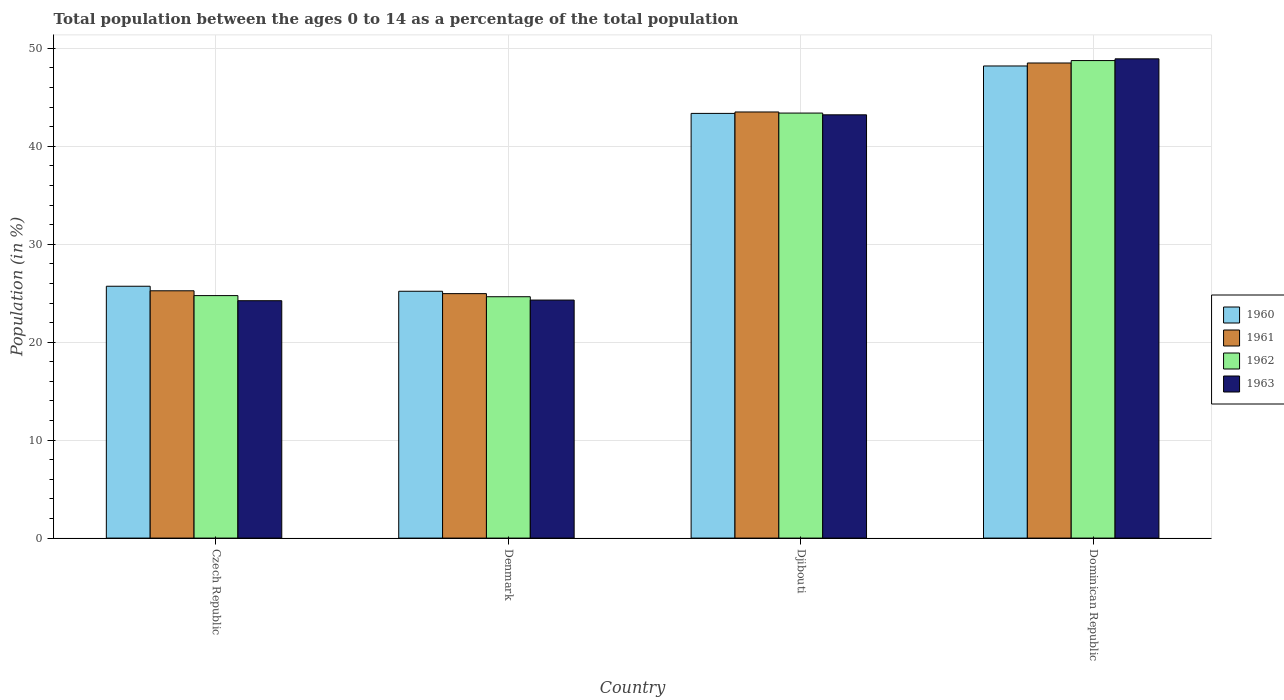How many different coloured bars are there?
Provide a short and direct response. 4. How many groups of bars are there?
Your answer should be very brief. 4. Are the number of bars per tick equal to the number of legend labels?
Your response must be concise. Yes. What is the label of the 3rd group of bars from the left?
Provide a succinct answer. Djibouti. In how many cases, is the number of bars for a given country not equal to the number of legend labels?
Provide a succinct answer. 0. What is the percentage of the population ages 0 to 14 in 1962 in Dominican Republic?
Your answer should be very brief. 48.75. Across all countries, what is the maximum percentage of the population ages 0 to 14 in 1963?
Ensure brevity in your answer.  48.93. Across all countries, what is the minimum percentage of the population ages 0 to 14 in 1962?
Offer a very short reply. 24.64. In which country was the percentage of the population ages 0 to 14 in 1962 maximum?
Ensure brevity in your answer.  Dominican Republic. What is the total percentage of the population ages 0 to 14 in 1962 in the graph?
Provide a short and direct response. 141.54. What is the difference between the percentage of the population ages 0 to 14 in 1961 in Czech Republic and that in Djibouti?
Make the answer very short. -18.26. What is the difference between the percentage of the population ages 0 to 14 in 1963 in Dominican Republic and the percentage of the population ages 0 to 14 in 1962 in Denmark?
Your answer should be compact. 24.29. What is the average percentage of the population ages 0 to 14 in 1960 per country?
Provide a succinct answer. 35.62. What is the difference between the percentage of the population ages 0 to 14 of/in 1960 and percentage of the population ages 0 to 14 of/in 1963 in Denmark?
Provide a short and direct response. 0.9. What is the ratio of the percentage of the population ages 0 to 14 in 1962 in Denmark to that in Djibouti?
Offer a very short reply. 0.57. Is the percentage of the population ages 0 to 14 in 1962 in Djibouti less than that in Dominican Republic?
Your answer should be compact. Yes. What is the difference between the highest and the second highest percentage of the population ages 0 to 14 in 1961?
Offer a terse response. 23.26. What is the difference between the highest and the lowest percentage of the population ages 0 to 14 in 1962?
Your answer should be very brief. 24.11. Is it the case that in every country, the sum of the percentage of the population ages 0 to 14 in 1961 and percentage of the population ages 0 to 14 in 1960 is greater than the sum of percentage of the population ages 0 to 14 in 1962 and percentage of the population ages 0 to 14 in 1963?
Your answer should be compact. No. How many bars are there?
Give a very brief answer. 16. What is the difference between two consecutive major ticks on the Y-axis?
Make the answer very short. 10. Are the values on the major ticks of Y-axis written in scientific E-notation?
Keep it short and to the point. No. Does the graph contain any zero values?
Provide a short and direct response. No. How are the legend labels stacked?
Provide a succinct answer. Vertical. What is the title of the graph?
Give a very brief answer. Total population between the ages 0 to 14 as a percentage of the total population. Does "1993" appear as one of the legend labels in the graph?
Offer a terse response. No. What is the label or title of the Y-axis?
Your answer should be compact. Population (in %). What is the Population (in %) of 1960 in Czech Republic?
Offer a very short reply. 25.71. What is the Population (in %) in 1961 in Czech Republic?
Ensure brevity in your answer.  25.25. What is the Population (in %) of 1962 in Czech Republic?
Make the answer very short. 24.76. What is the Population (in %) of 1963 in Czech Republic?
Offer a very short reply. 24.23. What is the Population (in %) of 1960 in Denmark?
Keep it short and to the point. 25.2. What is the Population (in %) of 1961 in Denmark?
Offer a terse response. 24.96. What is the Population (in %) of 1962 in Denmark?
Provide a succinct answer. 24.64. What is the Population (in %) in 1963 in Denmark?
Give a very brief answer. 24.3. What is the Population (in %) in 1960 in Djibouti?
Ensure brevity in your answer.  43.36. What is the Population (in %) of 1961 in Djibouti?
Offer a very short reply. 43.5. What is the Population (in %) in 1962 in Djibouti?
Keep it short and to the point. 43.39. What is the Population (in %) of 1963 in Djibouti?
Keep it short and to the point. 43.21. What is the Population (in %) of 1960 in Dominican Republic?
Make the answer very short. 48.2. What is the Population (in %) in 1961 in Dominican Republic?
Your answer should be very brief. 48.5. What is the Population (in %) in 1962 in Dominican Republic?
Give a very brief answer. 48.75. What is the Population (in %) of 1963 in Dominican Republic?
Ensure brevity in your answer.  48.93. Across all countries, what is the maximum Population (in %) in 1960?
Make the answer very short. 48.2. Across all countries, what is the maximum Population (in %) in 1961?
Your answer should be very brief. 48.5. Across all countries, what is the maximum Population (in %) in 1962?
Keep it short and to the point. 48.75. Across all countries, what is the maximum Population (in %) in 1963?
Offer a terse response. 48.93. Across all countries, what is the minimum Population (in %) in 1960?
Your response must be concise. 25.2. Across all countries, what is the minimum Population (in %) of 1961?
Make the answer very short. 24.96. Across all countries, what is the minimum Population (in %) of 1962?
Keep it short and to the point. 24.64. Across all countries, what is the minimum Population (in %) of 1963?
Make the answer very short. 24.23. What is the total Population (in %) of 1960 in the graph?
Provide a succinct answer. 142.47. What is the total Population (in %) of 1961 in the graph?
Your answer should be very brief. 142.22. What is the total Population (in %) in 1962 in the graph?
Keep it short and to the point. 141.54. What is the total Population (in %) of 1963 in the graph?
Your response must be concise. 140.68. What is the difference between the Population (in %) in 1960 in Czech Republic and that in Denmark?
Provide a succinct answer. 0.51. What is the difference between the Population (in %) of 1961 in Czech Republic and that in Denmark?
Provide a short and direct response. 0.29. What is the difference between the Population (in %) in 1962 in Czech Republic and that in Denmark?
Provide a succinct answer. 0.12. What is the difference between the Population (in %) of 1963 in Czech Republic and that in Denmark?
Ensure brevity in your answer.  -0.07. What is the difference between the Population (in %) in 1960 in Czech Republic and that in Djibouti?
Offer a terse response. -17.65. What is the difference between the Population (in %) in 1961 in Czech Republic and that in Djibouti?
Ensure brevity in your answer.  -18.26. What is the difference between the Population (in %) of 1962 in Czech Republic and that in Djibouti?
Give a very brief answer. -18.64. What is the difference between the Population (in %) of 1963 in Czech Republic and that in Djibouti?
Ensure brevity in your answer.  -18.98. What is the difference between the Population (in %) of 1960 in Czech Republic and that in Dominican Republic?
Provide a succinct answer. -22.49. What is the difference between the Population (in %) in 1961 in Czech Republic and that in Dominican Republic?
Offer a very short reply. -23.26. What is the difference between the Population (in %) in 1962 in Czech Republic and that in Dominican Republic?
Offer a terse response. -23.99. What is the difference between the Population (in %) of 1963 in Czech Republic and that in Dominican Republic?
Make the answer very short. -24.69. What is the difference between the Population (in %) in 1960 in Denmark and that in Djibouti?
Ensure brevity in your answer.  -18.16. What is the difference between the Population (in %) of 1961 in Denmark and that in Djibouti?
Your answer should be compact. -18.55. What is the difference between the Population (in %) in 1962 in Denmark and that in Djibouti?
Make the answer very short. -18.75. What is the difference between the Population (in %) of 1963 in Denmark and that in Djibouti?
Provide a succinct answer. -18.91. What is the difference between the Population (in %) of 1960 in Denmark and that in Dominican Republic?
Offer a terse response. -23. What is the difference between the Population (in %) in 1961 in Denmark and that in Dominican Republic?
Provide a succinct answer. -23.55. What is the difference between the Population (in %) in 1962 in Denmark and that in Dominican Republic?
Your answer should be compact. -24.11. What is the difference between the Population (in %) in 1963 in Denmark and that in Dominican Republic?
Ensure brevity in your answer.  -24.63. What is the difference between the Population (in %) of 1960 in Djibouti and that in Dominican Republic?
Give a very brief answer. -4.84. What is the difference between the Population (in %) in 1961 in Djibouti and that in Dominican Republic?
Give a very brief answer. -5. What is the difference between the Population (in %) of 1962 in Djibouti and that in Dominican Republic?
Ensure brevity in your answer.  -5.36. What is the difference between the Population (in %) in 1963 in Djibouti and that in Dominican Republic?
Make the answer very short. -5.72. What is the difference between the Population (in %) of 1960 in Czech Republic and the Population (in %) of 1961 in Denmark?
Provide a succinct answer. 0.75. What is the difference between the Population (in %) of 1960 in Czech Republic and the Population (in %) of 1962 in Denmark?
Your answer should be compact. 1.07. What is the difference between the Population (in %) of 1960 in Czech Republic and the Population (in %) of 1963 in Denmark?
Your answer should be compact. 1.41. What is the difference between the Population (in %) in 1961 in Czech Republic and the Population (in %) in 1962 in Denmark?
Keep it short and to the point. 0.61. What is the difference between the Population (in %) of 1961 in Czech Republic and the Population (in %) of 1963 in Denmark?
Keep it short and to the point. 0.95. What is the difference between the Population (in %) in 1962 in Czech Republic and the Population (in %) in 1963 in Denmark?
Your answer should be very brief. 0.46. What is the difference between the Population (in %) of 1960 in Czech Republic and the Population (in %) of 1961 in Djibouti?
Make the answer very short. -17.79. What is the difference between the Population (in %) of 1960 in Czech Republic and the Population (in %) of 1962 in Djibouti?
Give a very brief answer. -17.68. What is the difference between the Population (in %) of 1960 in Czech Republic and the Population (in %) of 1963 in Djibouti?
Provide a succinct answer. -17.5. What is the difference between the Population (in %) of 1961 in Czech Republic and the Population (in %) of 1962 in Djibouti?
Make the answer very short. -18.14. What is the difference between the Population (in %) in 1961 in Czech Republic and the Population (in %) in 1963 in Djibouti?
Your answer should be very brief. -17.96. What is the difference between the Population (in %) of 1962 in Czech Republic and the Population (in %) of 1963 in Djibouti?
Make the answer very short. -18.46. What is the difference between the Population (in %) in 1960 in Czech Republic and the Population (in %) in 1961 in Dominican Republic?
Offer a terse response. -22.79. What is the difference between the Population (in %) in 1960 in Czech Republic and the Population (in %) in 1962 in Dominican Republic?
Keep it short and to the point. -23.04. What is the difference between the Population (in %) in 1960 in Czech Republic and the Population (in %) in 1963 in Dominican Republic?
Ensure brevity in your answer.  -23.22. What is the difference between the Population (in %) of 1961 in Czech Republic and the Population (in %) of 1962 in Dominican Republic?
Ensure brevity in your answer.  -23.5. What is the difference between the Population (in %) in 1961 in Czech Republic and the Population (in %) in 1963 in Dominican Republic?
Ensure brevity in your answer.  -23.68. What is the difference between the Population (in %) of 1962 in Czech Republic and the Population (in %) of 1963 in Dominican Republic?
Ensure brevity in your answer.  -24.17. What is the difference between the Population (in %) in 1960 in Denmark and the Population (in %) in 1961 in Djibouti?
Your answer should be very brief. -18.3. What is the difference between the Population (in %) in 1960 in Denmark and the Population (in %) in 1962 in Djibouti?
Your answer should be compact. -18.19. What is the difference between the Population (in %) in 1960 in Denmark and the Population (in %) in 1963 in Djibouti?
Your answer should be compact. -18.01. What is the difference between the Population (in %) of 1961 in Denmark and the Population (in %) of 1962 in Djibouti?
Offer a terse response. -18.43. What is the difference between the Population (in %) of 1961 in Denmark and the Population (in %) of 1963 in Djibouti?
Your answer should be compact. -18.25. What is the difference between the Population (in %) in 1962 in Denmark and the Population (in %) in 1963 in Djibouti?
Make the answer very short. -18.57. What is the difference between the Population (in %) of 1960 in Denmark and the Population (in %) of 1961 in Dominican Republic?
Offer a terse response. -23.3. What is the difference between the Population (in %) of 1960 in Denmark and the Population (in %) of 1962 in Dominican Republic?
Ensure brevity in your answer.  -23.55. What is the difference between the Population (in %) in 1960 in Denmark and the Population (in %) in 1963 in Dominican Republic?
Your answer should be compact. -23.73. What is the difference between the Population (in %) of 1961 in Denmark and the Population (in %) of 1962 in Dominican Republic?
Offer a very short reply. -23.79. What is the difference between the Population (in %) in 1961 in Denmark and the Population (in %) in 1963 in Dominican Republic?
Your response must be concise. -23.97. What is the difference between the Population (in %) of 1962 in Denmark and the Population (in %) of 1963 in Dominican Republic?
Offer a very short reply. -24.29. What is the difference between the Population (in %) of 1960 in Djibouti and the Population (in %) of 1961 in Dominican Republic?
Offer a very short reply. -5.15. What is the difference between the Population (in %) of 1960 in Djibouti and the Population (in %) of 1962 in Dominican Republic?
Provide a short and direct response. -5.39. What is the difference between the Population (in %) of 1960 in Djibouti and the Population (in %) of 1963 in Dominican Republic?
Your answer should be very brief. -5.57. What is the difference between the Population (in %) in 1961 in Djibouti and the Population (in %) in 1962 in Dominican Republic?
Your answer should be very brief. -5.25. What is the difference between the Population (in %) of 1961 in Djibouti and the Population (in %) of 1963 in Dominican Republic?
Offer a terse response. -5.42. What is the difference between the Population (in %) of 1962 in Djibouti and the Population (in %) of 1963 in Dominican Republic?
Make the answer very short. -5.54. What is the average Population (in %) in 1960 per country?
Make the answer very short. 35.62. What is the average Population (in %) in 1961 per country?
Keep it short and to the point. 35.55. What is the average Population (in %) of 1962 per country?
Your answer should be compact. 35.39. What is the average Population (in %) of 1963 per country?
Your response must be concise. 35.17. What is the difference between the Population (in %) in 1960 and Population (in %) in 1961 in Czech Republic?
Offer a terse response. 0.46. What is the difference between the Population (in %) of 1960 and Population (in %) of 1962 in Czech Republic?
Your response must be concise. 0.95. What is the difference between the Population (in %) of 1960 and Population (in %) of 1963 in Czech Republic?
Ensure brevity in your answer.  1.48. What is the difference between the Population (in %) of 1961 and Population (in %) of 1962 in Czech Republic?
Your answer should be compact. 0.49. What is the difference between the Population (in %) of 1961 and Population (in %) of 1963 in Czech Republic?
Your answer should be very brief. 1.01. What is the difference between the Population (in %) in 1962 and Population (in %) in 1963 in Czech Republic?
Make the answer very short. 0.52. What is the difference between the Population (in %) in 1960 and Population (in %) in 1961 in Denmark?
Keep it short and to the point. 0.24. What is the difference between the Population (in %) in 1960 and Population (in %) in 1962 in Denmark?
Give a very brief answer. 0.56. What is the difference between the Population (in %) of 1960 and Population (in %) of 1963 in Denmark?
Ensure brevity in your answer.  0.9. What is the difference between the Population (in %) in 1961 and Population (in %) in 1962 in Denmark?
Your answer should be compact. 0.32. What is the difference between the Population (in %) in 1961 and Population (in %) in 1963 in Denmark?
Offer a terse response. 0.66. What is the difference between the Population (in %) in 1962 and Population (in %) in 1963 in Denmark?
Offer a very short reply. 0.34. What is the difference between the Population (in %) of 1960 and Population (in %) of 1961 in Djibouti?
Give a very brief answer. -0.15. What is the difference between the Population (in %) in 1960 and Population (in %) in 1962 in Djibouti?
Your response must be concise. -0.03. What is the difference between the Population (in %) in 1960 and Population (in %) in 1963 in Djibouti?
Your response must be concise. 0.14. What is the difference between the Population (in %) of 1961 and Population (in %) of 1962 in Djibouti?
Your answer should be compact. 0.11. What is the difference between the Population (in %) in 1961 and Population (in %) in 1963 in Djibouti?
Offer a very short reply. 0.29. What is the difference between the Population (in %) in 1962 and Population (in %) in 1963 in Djibouti?
Provide a short and direct response. 0.18. What is the difference between the Population (in %) in 1960 and Population (in %) in 1961 in Dominican Republic?
Offer a terse response. -0.3. What is the difference between the Population (in %) in 1960 and Population (in %) in 1962 in Dominican Republic?
Provide a succinct answer. -0.55. What is the difference between the Population (in %) of 1960 and Population (in %) of 1963 in Dominican Republic?
Offer a very short reply. -0.73. What is the difference between the Population (in %) in 1961 and Population (in %) in 1962 in Dominican Republic?
Offer a very short reply. -0.25. What is the difference between the Population (in %) in 1961 and Population (in %) in 1963 in Dominican Republic?
Your answer should be very brief. -0.42. What is the difference between the Population (in %) of 1962 and Population (in %) of 1963 in Dominican Republic?
Give a very brief answer. -0.18. What is the ratio of the Population (in %) of 1960 in Czech Republic to that in Denmark?
Provide a succinct answer. 1.02. What is the ratio of the Population (in %) of 1961 in Czech Republic to that in Denmark?
Give a very brief answer. 1.01. What is the ratio of the Population (in %) of 1962 in Czech Republic to that in Denmark?
Offer a terse response. 1. What is the ratio of the Population (in %) of 1963 in Czech Republic to that in Denmark?
Provide a succinct answer. 1. What is the ratio of the Population (in %) in 1960 in Czech Republic to that in Djibouti?
Your response must be concise. 0.59. What is the ratio of the Population (in %) in 1961 in Czech Republic to that in Djibouti?
Your response must be concise. 0.58. What is the ratio of the Population (in %) of 1962 in Czech Republic to that in Djibouti?
Keep it short and to the point. 0.57. What is the ratio of the Population (in %) of 1963 in Czech Republic to that in Djibouti?
Your answer should be compact. 0.56. What is the ratio of the Population (in %) in 1960 in Czech Republic to that in Dominican Republic?
Ensure brevity in your answer.  0.53. What is the ratio of the Population (in %) in 1961 in Czech Republic to that in Dominican Republic?
Your answer should be compact. 0.52. What is the ratio of the Population (in %) in 1962 in Czech Republic to that in Dominican Republic?
Offer a very short reply. 0.51. What is the ratio of the Population (in %) in 1963 in Czech Republic to that in Dominican Republic?
Your response must be concise. 0.5. What is the ratio of the Population (in %) in 1960 in Denmark to that in Djibouti?
Offer a terse response. 0.58. What is the ratio of the Population (in %) in 1961 in Denmark to that in Djibouti?
Give a very brief answer. 0.57. What is the ratio of the Population (in %) in 1962 in Denmark to that in Djibouti?
Give a very brief answer. 0.57. What is the ratio of the Population (in %) in 1963 in Denmark to that in Djibouti?
Offer a terse response. 0.56. What is the ratio of the Population (in %) of 1960 in Denmark to that in Dominican Republic?
Offer a very short reply. 0.52. What is the ratio of the Population (in %) in 1961 in Denmark to that in Dominican Republic?
Make the answer very short. 0.51. What is the ratio of the Population (in %) of 1962 in Denmark to that in Dominican Republic?
Keep it short and to the point. 0.51. What is the ratio of the Population (in %) in 1963 in Denmark to that in Dominican Republic?
Your answer should be compact. 0.5. What is the ratio of the Population (in %) of 1960 in Djibouti to that in Dominican Republic?
Provide a succinct answer. 0.9. What is the ratio of the Population (in %) of 1961 in Djibouti to that in Dominican Republic?
Provide a short and direct response. 0.9. What is the ratio of the Population (in %) in 1962 in Djibouti to that in Dominican Republic?
Your response must be concise. 0.89. What is the ratio of the Population (in %) of 1963 in Djibouti to that in Dominican Republic?
Ensure brevity in your answer.  0.88. What is the difference between the highest and the second highest Population (in %) in 1960?
Ensure brevity in your answer.  4.84. What is the difference between the highest and the second highest Population (in %) of 1961?
Make the answer very short. 5. What is the difference between the highest and the second highest Population (in %) of 1962?
Offer a terse response. 5.36. What is the difference between the highest and the second highest Population (in %) in 1963?
Make the answer very short. 5.72. What is the difference between the highest and the lowest Population (in %) of 1960?
Make the answer very short. 23. What is the difference between the highest and the lowest Population (in %) of 1961?
Provide a short and direct response. 23.55. What is the difference between the highest and the lowest Population (in %) in 1962?
Offer a terse response. 24.11. What is the difference between the highest and the lowest Population (in %) of 1963?
Provide a succinct answer. 24.69. 